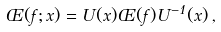<formula> <loc_0><loc_0><loc_500><loc_500>\phi ( f ; x ) = U ( x ) \phi ( f ) U ^ { - 1 } ( x ) \, ,</formula> 